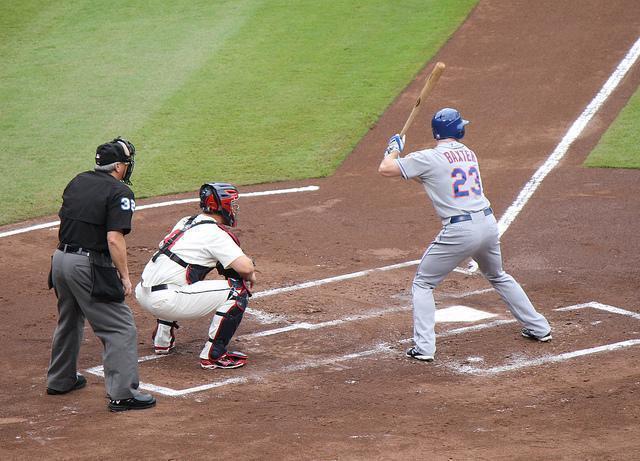Who is the away team?
From the following set of four choices, select the accurate answer to respond to the question.
Options: Pirates, angels, mets, yankees. Yankees. 